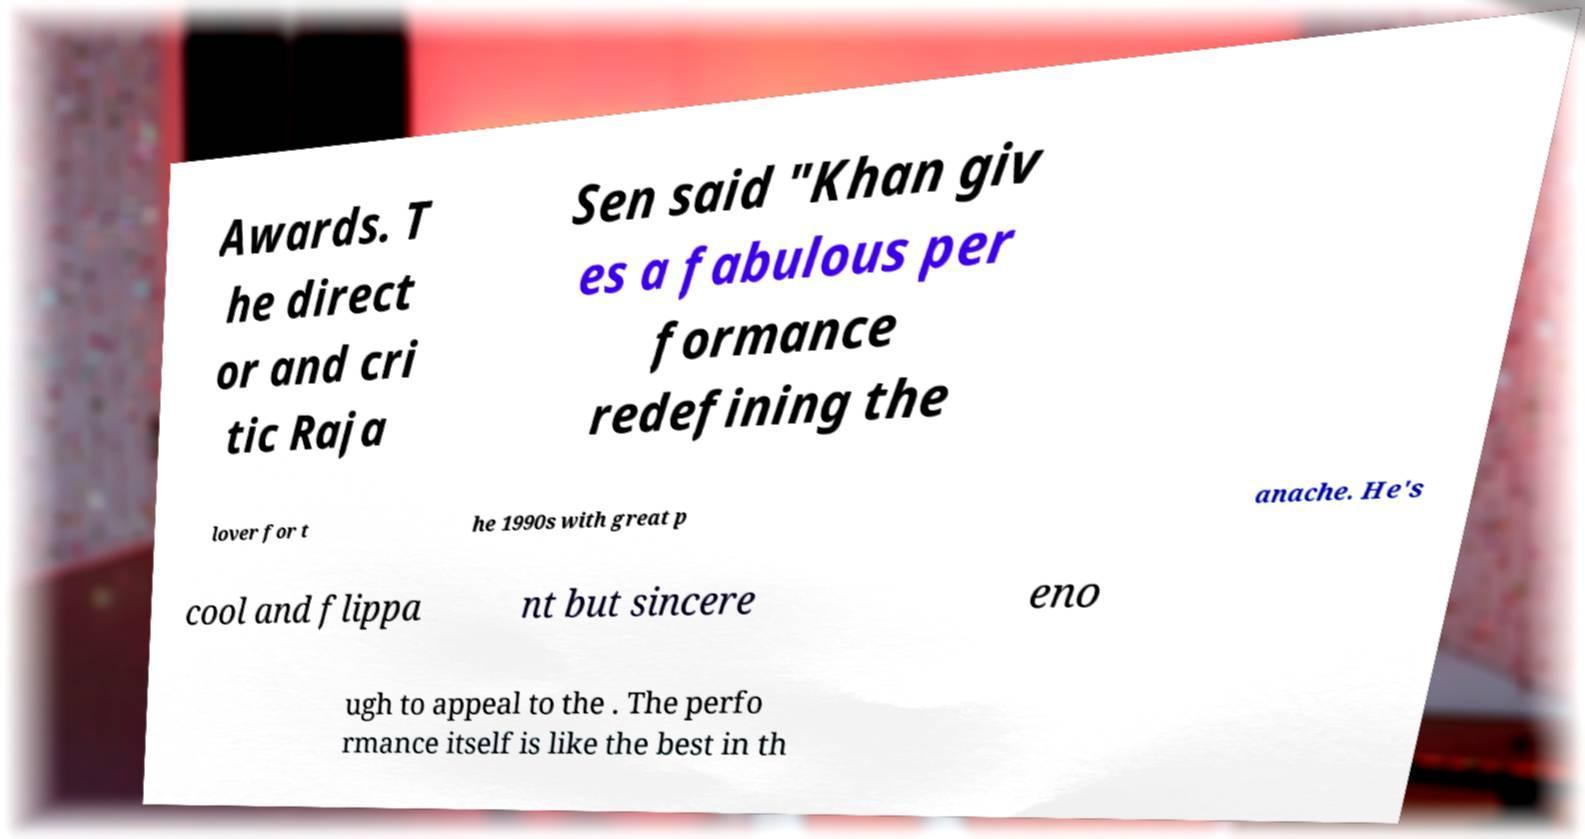What messages or text are displayed in this image? I need them in a readable, typed format. Awards. T he direct or and cri tic Raja Sen said "Khan giv es a fabulous per formance redefining the lover for t he 1990s with great p anache. He's cool and flippa nt but sincere eno ugh to appeal to the . The perfo rmance itself is like the best in th 